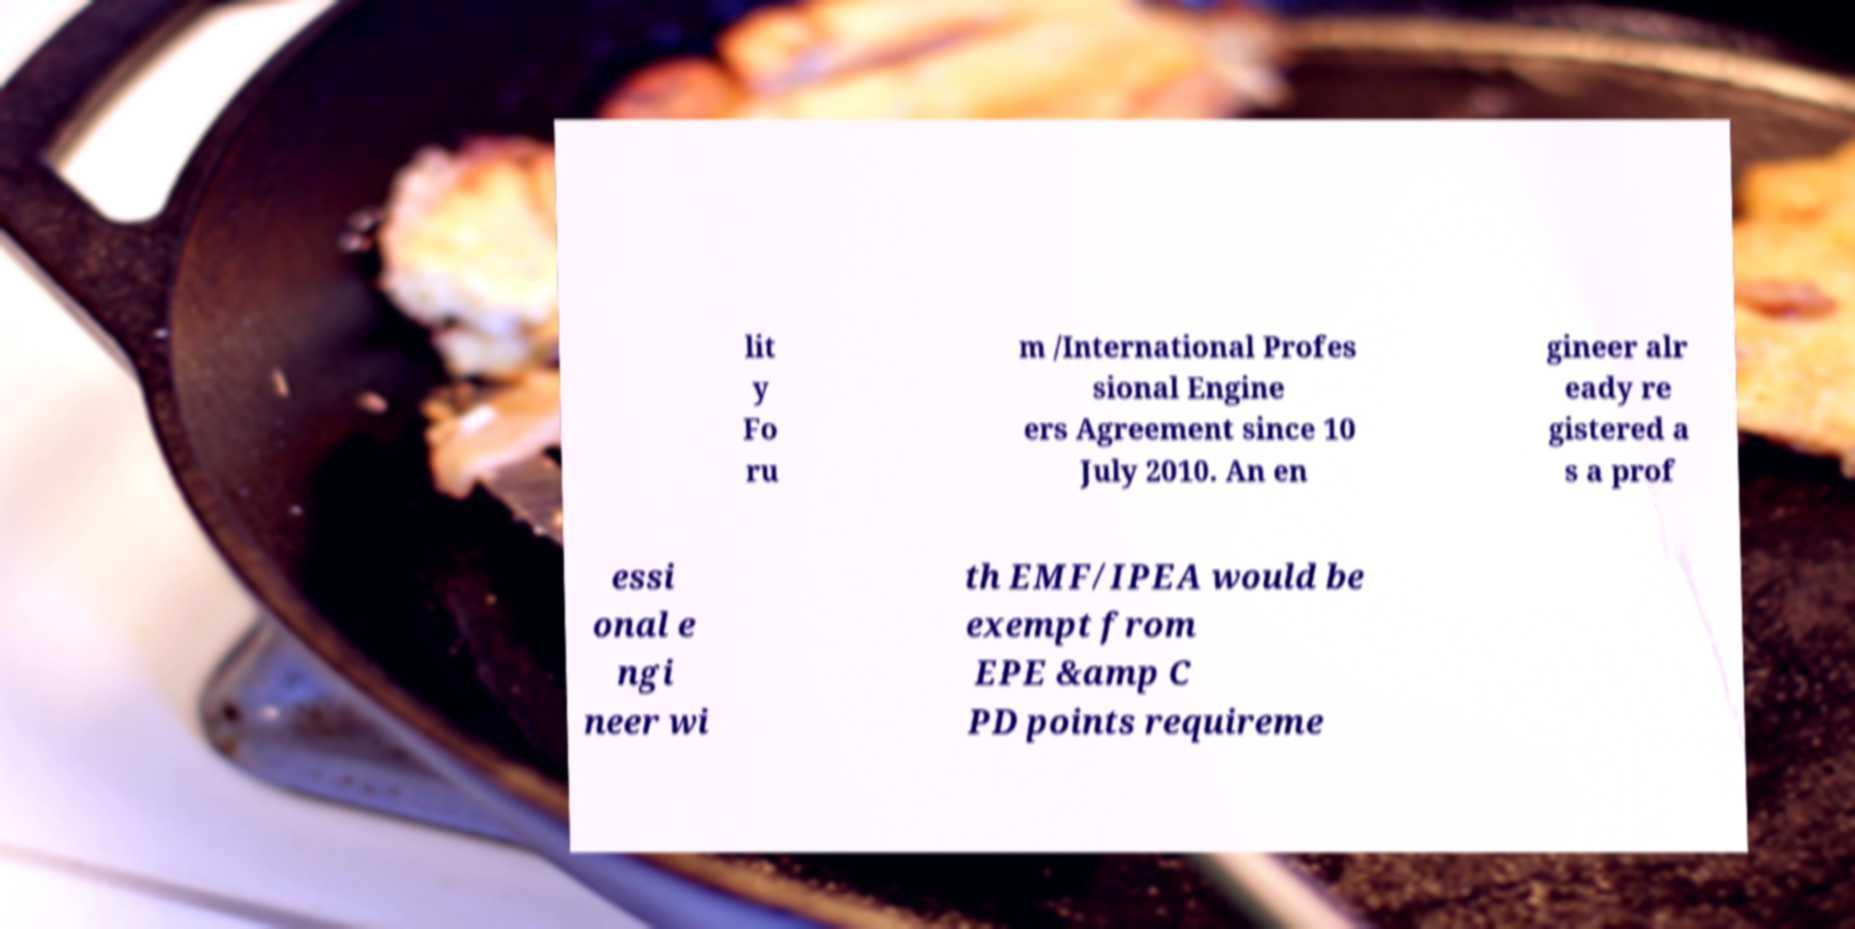I need the written content from this picture converted into text. Can you do that? lit y Fo ru m /International Profes sional Engine ers Agreement since 10 July 2010. An en gineer alr eady re gistered a s a prof essi onal e ngi neer wi th EMF/IPEA would be exempt from EPE &amp C PD points requireme 